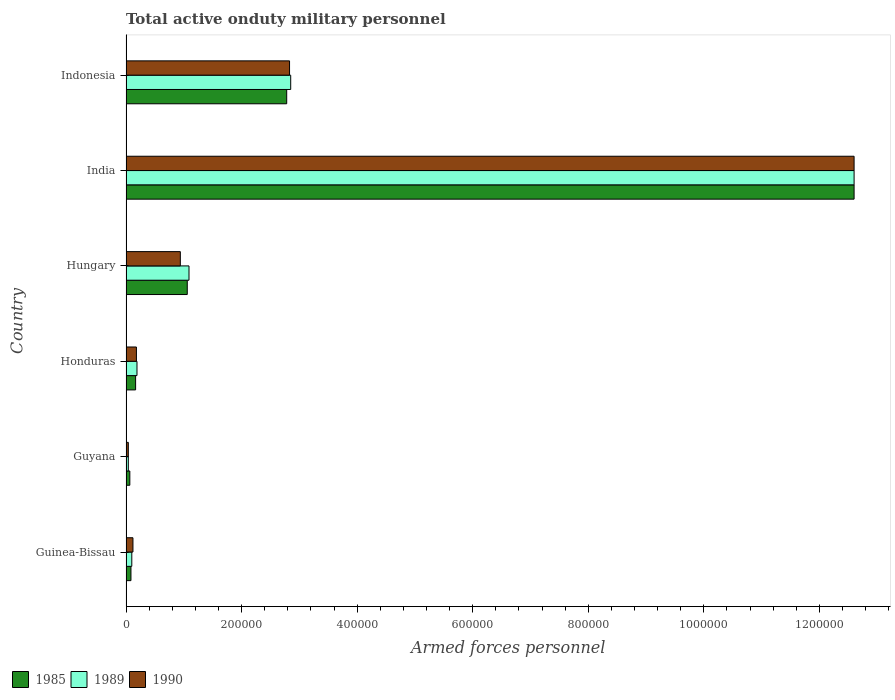Are the number of bars per tick equal to the number of legend labels?
Your answer should be very brief. Yes. How many bars are there on the 3rd tick from the top?
Ensure brevity in your answer.  3. What is the number of armed forces personnel in 1985 in Guyana?
Your response must be concise. 6600. Across all countries, what is the maximum number of armed forces personnel in 1989?
Your answer should be compact. 1.26e+06. Across all countries, what is the minimum number of armed forces personnel in 1989?
Keep it short and to the point. 4000. In which country was the number of armed forces personnel in 1985 minimum?
Give a very brief answer. Guyana. What is the total number of armed forces personnel in 1990 in the graph?
Offer a terse response. 1.67e+06. What is the difference between the number of armed forces personnel in 1985 in Hungary and that in India?
Give a very brief answer. -1.15e+06. What is the difference between the number of armed forces personnel in 1989 in Honduras and the number of armed forces personnel in 1985 in Hungary?
Offer a terse response. -8.70e+04. What is the average number of armed forces personnel in 1990 per country?
Make the answer very short. 2.78e+05. In how many countries, is the number of armed forces personnel in 1989 greater than 440000 ?
Keep it short and to the point. 1. What is the ratio of the number of armed forces personnel in 1990 in Hungary to that in Indonesia?
Your answer should be compact. 0.33. Is the difference between the number of armed forces personnel in 1989 in Honduras and India greater than the difference between the number of armed forces personnel in 1990 in Honduras and India?
Ensure brevity in your answer.  Yes. What is the difference between the highest and the second highest number of armed forces personnel in 1985?
Your answer should be compact. 9.82e+05. What is the difference between the highest and the lowest number of armed forces personnel in 1989?
Offer a very short reply. 1.26e+06. What does the 1st bar from the top in Indonesia represents?
Ensure brevity in your answer.  1990. What does the 3rd bar from the bottom in Guinea-Bissau represents?
Your response must be concise. 1990. Is it the case that in every country, the sum of the number of armed forces personnel in 1990 and number of armed forces personnel in 1989 is greater than the number of armed forces personnel in 1985?
Give a very brief answer. Yes. How many bars are there?
Offer a very short reply. 18. How many countries are there in the graph?
Offer a terse response. 6. What is the difference between two consecutive major ticks on the X-axis?
Ensure brevity in your answer.  2.00e+05. What is the title of the graph?
Keep it short and to the point. Total active onduty military personnel. What is the label or title of the X-axis?
Ensure brevity in your answer.  Armed forces personnel. What is the label or title of the Y-axis?
Keep it short and to the point. Country. What is the Armed forces personnel of 1985 in Guinea-Bissau?
Give a very brief answer. 8550. What is the Armed forces personnel in 1989 in Guinea-Bissau?
Offer a terse response. 10000. What is the Armed forces personnel of 1990 in Guinea-Bissau?
Ensure brevity in your answer.  1.20e+04. What is the Armed forces personnel of 1985 in Guyana?
Provide a short and direct response. 6600. What is the Armed forces personnel in 1989 in Guyana?
Provide a succinct answer. 4000. What is the Armed forces personnel in 1990 in Guyana?
Provide a short and direct response. 4000. What is the Armed forces personnel in 1985 in Honduras?
Give a very brief answer. 1.66e+04. What is the Armed forces personnel in 1989 in Honduras?
Make the answer very short. 1.90e+04. What is the Armed forces personnel in 1990 in Honduras?
Offer a very short reply. 1.80e+04. What is the Armed forces personnel of 1985 in Hungary?
Your answer should be compact. 1.06e+05. What is the Armed forces personnel in 1989 in Hungary?
Offer a very short reply. 1.09e+05. What is the Armed forces personnel in 1990 in Hungary?
Make the answer very short. 9.40e+04. What is the Armed forces personnel in 1985 in India?
Provide a short and direct response. 1.26e+06. What is the Armed forces personnel in 1989 in India?
Your response must be concise. 1.26e+06. What is the Armed forces personnel in 1990 in India?
Offer a terse response. 1.26e+06. What is the Armed forces personnel of 1985 in Indonesia?
Your answer should be compact. 2.78e+05. What is the Armed forces personnel of 1989 in Indonesia?
Ensure brevity in your answer.  2.85e+05. What is the Armed forces personnel of 1990 in Indonesia?
Make the answer very short. 2.83e+05. Across all countries, what is the maximum Armed forces personnel in 1985?
Give a very brief answer. 1.26e+06. Across all countries, what is the maximum Armed forces personnel in 1989?
Your response must be concise. 1.26e+06. Across all countries, what is the maximum Armed forces personnel of 1990?
Provide a short and direct response. 1.26e+06. Across all countries, what is the minimum Armed forces personnel in 1985?
Ensure brevity in your answer.  6600. Across all countries, what is the minimum Armed forces personnel of 1989?
Ensure brevity in your answer.  4000. Across all countries, what is the minimum Armed forces personnel of 1990?
Keep it short and to the point. 4000. What is the total Armed forces personnel of 1985 in the graph?
Your answer should be very brief. 1.68e+06. What is the total Armed forces personnel of 1989 in the graph?
Provide a succinct answer. 1.69e+06. What is the total Armed forces personnel in 1990 in the graph?
Make the answer very short. 1.67e+06. What is the difference between the Armed forces personnel in 1985 in Guinea-Bissau and that in Guyana?
Your answer should be compact. 1950. What is the difference between the Armed forces personnel in 1989 in Guinea-Bissau and that in Guyana?
Provide a short and direct response. 6000. What is the difference between the Armed forces personnel of 1990 in Guinea-Bissau and that in Guyana?
Provide a short and direct response. 8000. What is the difference between the Armed forces personnel in 1985 in Guinea-Bissau and that in Honduras?
Give a very brief answer. -8050. What is the difference between the Armed forces personnel in 1989 in Guinea-Bissau and that in Honduras?
Ensure brevity in your answer.  -9000. What is the difference between the Armed forces personnel in 1990 in Guinea-Bissau and that in Honduras?
Offer a terse response. -6000. What is the difference between the Armed forces personnel in 1985 in Guinea-Bissau and that in Hungary?
Your response must be concise. -9.74e+04. What is the difference between the Armed forces personnel in 1989 in Guinea-Bissau and that in Hungary?
Your answer should be compact. -9.90e+04. What is the difference between the Armed forces personnel of 1990 in Guinea-Bissau and that in Hungary?
Your response must be concise. -8.20e+04. What is the difference between the Armed forces personnel of 1985 in Guinea-Bissau and that in India?
Make the answer very short. -1.25e+06. What is the difference between the Armed forces personnel in 1989 in Guinea-Bissau and that in India?
Give a very brief answer. -1.25e+06. What is the difference between the Armed forces personnel in 1990 in Guinea-Bissau and that in India?
Give a very brief answer. -1.25e+06. What is the difference between the Armed forces personnel in 1985 in Guinea-Bissau and that in Indonesia?
Your response must be concise. -2.70e+05. What is the difference between the Armed forces personnel of 1989 in Guinea-Bissau and that in Indonesia?
Provide a succinct answer. -2.75e+05. What is the difference between the Armed forces personnel in 1990 in Guinea-Bissau and that in Indonesia?
Offer a very short reply. -2.71e+05. What is the difference between the Armed forces personnel in 1985 in Guyana and that in Honduras?
Offer a very short reply. -10000. What is the difference between the Armed forces personnel in 1989 in Guyana and that in Honduras?
Your answer should be very brief. -1.50e+04. What is the difference between the Armed forces personnel of 1990 in Guyana and that in Honduras?
Provide a short and direct response. -1.40e+04. What is the difference between the Armed forces personnel of 1985 in Guyana and that in Hungary?
Provide a short and direct response. -9.94e+04. What is the difference between the Armed forces personnel in 1989 in Guyana and that in Hungary?
Ensure brevity in your answer.  -1.05e+05. What is the difference between the Armed forces personnel of 1990 in Guyana and that in Hungary?
Provide a short and direct response. -9.00e+04. What is the difference between the Armed forces personnel in 1985 in Guyana and that in India?
Your answer should be compact. -1.25e+06. What is the difference between the Armed forces personnel in 1989 in Guyana and that in India?
Provide a succinct answer. -1.26e+06. What is the difference between the Armed forces personnel in 1990 in Guyana and that in India?
Make the answer very short. -1.26e+06. What is the difference between the Armed forces personnel in 1985 in Guyana and that in Indonesia?
Keep it short and to the point. -2.72e+05. What is the difference between the Armed forces personnel in 1989 in Guyana and that in Indonesia?
Keep it short and to the point. -2.81e+05. What is the difference between the Armed forces personnel in 1990 in Guyana and that in Indonesia?
Your answer should be very brief. -2.79e+05. What is the difference between the Armed forces personnel in 1985 in Honduras and that in Hungary?
Your answer should be compact. -8.94e+04. What is the difference between the Armed forces personnel in 1989 in Honduras and that in Hungary?
Your answer should be compact. -9.00e+04. What is the difference between the Armed forces personnel in 1990 in Honduras and that in Hungary?
Make the answer very short. -7.60e+04. What is the difference between the Armed forces personnel of 1985 in Honduras and that in India?
Make the answer very short. -1.24e+06. What is the difference between the Armed forces personnel in 1989 in Honduras and that in India?
Offer a very short reply. -1.24e+06. What is the difference between the Armed forces personnel of 1990 in Honduras and that in India?
Make the answer very short. -1.24e+06. What is the difference between the Armed forces personnel in 1985 in Honduras and that in Indonesia?
Your answer should be very brief. -2.62e+05. What is the difference between the Armed forces personnel in 1989 in Honduras and that in Indonesia?
Make the answer very short. -2.66e+05. What is the difference between the Armed forces personnel in 1990 in Honduras and that in Indonesia?
Ensure brevity in your answer.  -2.65e+05. What is the difference between the Armed forces personnel of 1985 in Hungary and that in India?
Ensure brevity in your answer.  -1.15e+06. What is the difference between the Armed forces personnel in 1989 in Hungary and that in India?
Ensure brevity in your answer.  -1.15e+06. What is the difference between the Armed forces personnel of 1990 in Hungary and that in India?
Provide a short and direct response. -1.17e+06. What is the difference between the Armed forces personnel in 1985 in Hungary and that in Indonesia?
Provide a short and direct response. -1.72e+05. What is the difference between the Armed forces personnel of 1989 in Hungary and that in Indonesia?
Give a very brief answer. -1.76e+05. What is the difference between the Armed forces personnel in 1990 in Hungary and that in Indonesia?
Give a very brief answer. -1.89e+05. What is the difference between the Armed forces personnel in 1985 in India and that in Indonesia?
Offer a very short reply. 9.82e+05. What is the difference between the Armed forces personnel of 1989 in India and that in Indonesia?
Your response must be concise. 9.75e+05. What is the difference between the Armed forces personnel of 1990 in India and that in Indonesia?
Ensure brevity in your answer.  9.77e+05. What is the difference between the Armed forces personnel of 1985 in Guinea-Bissau and the Armed forces personnel of 1989 in Guyana?
Offer a very short reply. 4550. What is the difference between the Armed forces personnel of 1985 in Guinea-Bissau and the Armed forces personnel of 1990 in Guyana?
Ensure brevity in your answer.  4550. What is the difference between the Armed forces personnel of 1989 in Guinea-Bissau and the Armed forces personnel of 1990 in Guyana?
Your response must be concise. 6000. What is the difference between the Armed forces personnel of 1985 in Guinea-Bissau and the Armed forces personnel of 1989 in Honduras?
Provide a succinct answer. -1.04e+04. What is the difference between the Armed forces personnel of 1985 in Guinea-Bissau and the Armed forces personnel of 1990 in Honduras?
Provide a succinct answer. -9450. What is the difference between the Armed forces personnel of 1989 in Guinea-Bissau and the Armed forces personnel of 1990 in Honduras?
Provide a succinct answer. -8000. What is the difference between the Armed forces personnel in 1985 in Guinea-Bissau and the Armed forces personnel in 1989 in Hungary?
Your answer should be compact. -1.00e+05. What is the difference between the Armed forces personnel in 1985 in Guinea-Bissau and the Armed forces personnel in 1990 in Hungary?
Provide a short and direct response. -8.54e+04. What is the difference between the Armed forces personnel of 1989 in Guinea-Bissau and the Armed forces personnel of 1990 in Hungary?
Keep it short and to the point. -8.40e+04. What is the difference between the Armed forces personnel in 1985 in Guinea-Bissau and the Armed forces personnel in 1989 in India?
Provide a succinct answer. -1.25e+06. What is the difference between the Armed forces personnel of 1985 in Guinea-Bissau and the Armed forces personnel of 1990 in India?
Your answer should be very brief. -1.25e+06. What is the difference between the Armed forces personnel of 1989 in Guinea-Bissau and the Armed forces personnel of 1990 in India?
Ensure brevity in your answer.  -1.25e+06. What is the difference between the Armed forces personnel of 1985 in Guinea-Bissau and the Armed forces personnel of 1989 in Indonesia?
Make the answer very short. -2.76e+05. What is the difference between the Armed forces personnel in 1985 in Guinea-Bissau and the Armed forces personnel in 1990 in Indonesia?
Make the answer very short. -2.74e+05. What is the difference between the Armed forces personnel of 1989 in Guinea-Bissau and the Armed forces personnel of 1990 in Indonesia?
Offer a terse response. -2.73e+05. What is the difference between the Armed forces personnel in 1985 in Guyana and the Armed forces personnel in 1989 in Honduras?
Provide a short and direct response. -1.24e+04. What is the difference between the Armed forces personnel of 1985 in Guyana and the Armed forces personnel of 1990 in Honduras?
Make the answer very short. -1.14e+04. What is the difference between the Armed forces personnel of 1989 in Guyana and the Armed forces personnel of 1990 in Honduras?
Make the answer very short. -1.40e+04. What is the difference between the Armed forces personnel of 1985 in Guyana and the Armed forces personnel of 1989 in Hungary?
Your answer should be very brief. -1.02e+05. What is the difference between the Armed forces personnel in 1985 in Guyana and the Armed forces personnel in 1990 in Hungary?
Give a very brief answer. -8.74e+04. What is the difference between the Armed forces personnel in 1985 in Guyana and the Armed forces personnel in 1989 in India?
Offer a very short reply. -1.25e+06. What is the difference between the Armed forces personnel in 1985 in Guyana and the Armed forces personnel in 1990 in India?
Provide a succinct answer. -1.25e+06. What is the difference between the Armed forces personnel in 1989 in Guyana and the Armed forces personnel in 1990 in India?
Your answer should be compact. -1.26e+06. What is the difference between the Armed forces personnel in 1985 in Guyana and the Armed forces personnel in 1989 in Indonesia?
Provide a short and direct response. -2.78e+05. What is the difference between the Armed forces personnel in 1985 in Guyana and the Armed forces personnel in 1990 in Indonesia?
Ensure brevity in your answer.  -2.76e+05. What is the difference between the Armed forces personnel in 1989 in Guyana and the Armed forces personnel in 1990 in Indonesia?
Your response must be concise. -2.79e+05. What is the difference between the Armed forces personnel in 1985 in Honduras and the Armed forces personnel in 1989 in Hungary?
Keep it short and to the point. -9.24e+04. What is the difference between the Armed forces personnel in 1985 in Honduras and the Armed forces personnel in 1990 in Hungary?
Keep it short and to the point. -7.74e+04. What is the difference between the Armed forces personnel of 1989 in Honduras and the Armed forces personnel of 1990 in Hungary?
Offer a very short reply. -7.50e+04. What is the difference between the Armed forces personnel of 1985 in Honduras and the Armed forces personnel of 1989 in India?
Your answer should be compact. -1.24e+06. What is the difference between the Armed forces personnel of 1985 in Honduras and the Armed forces personnel of 1990 in India?
Ensure brevity in your answer.  -1.24e+06. What is the difference between the Armed forces personnel of 1989 in Honduras and the Armed forces personnel of 1990 in India?
Provide a short and direct response. -1.24e+06. What is the difference between the Armed forces personnel in 1985 in Honduras and the Armed forces personnel in 1989 in Indonesia?
Your response must be concise. -2.68e+05. What is the difference between the Armed forces personnel in 1985 in Honduras and the Armed forces personnel in 1990 in Indonesia?
Provide a short and direct response. -2.66e+05. What is the difference between the Armed forces personnel in 1989 in Honduras and the Armed forces personnel in 1990 in Indonesia?
Make the answer very short. -2.64e+05. What is the difference between the Armed forces personnel in 1985 in Hungary and the Armed forces personnel in 1989 in India?
Give a very brief answer. -1.15e+06. What is the difference between the Armed forces personnel of 1985 in Hungary and the Armed forces personnel of 1990 in India?
Your response must be concise. -1.15e+06. What is the difference between the Armed forces personnel in 1989 in Hungary and the Armed forces personnel in 1990 in India?
Provide a succinct answer. -1.15e+06. What is the difference between the Armed forces personnel of 1985 in Hungary and the Armed forces personnel of 1989 in Indonesia?
Make the answer very short. -1.79e+05. What is the difference between the Armed forces personnel in 1985 in Hungary and the Armed forces personnel in 1990 in Indonesia?
Make the answer very short. -1.77e+05. What is the difference between the Armed forces personnel of 1989 in Hungary and the Armed forces personnel of 1990 in Indonesia?
Offer a terse response. -1.74e+05. What is the difference between the Armed forces personnel of 1985 in India and the Armed forces personnel of 1989 in Indonesia?
Make the answer very short. 9.75e+05. What is the difference between the Armed forces personnel of 1985 in India and the Armed forces personnel of 1990 in Indonesia?
Keep it short and to the point. 9.77e+05. What is the difference between the Armed forces personnel in 1989 in India and the Armed forces personnel in 1990 in Indonesia?
Make the answer very short. 9.77e+05. What is the average Armed forces personnel of 1985 per country?
Offer a very short reply. 2.79e+05. What is the average Armed forces personnel of 1989 per country?
Your answer should be compact. 2.81e+05. What is the average Armed forces personnel of 1990 per country?
Your answer should be compact. 2.78e+05. What is the difference between the Armed forces personnel in 1985 and Armed forces personnel in 1989 in Guinea-Bissau?
Make the answer very short. -1450. What is the difference between the Armed forces personnel in 1985 and Armed forces personnel in 1990 in Guinea-Bissau?
Provide a short and direct response. -3450. What is the difference between the Armed forces personnel of 1989 and Armed forces personnel of 1990 in Guinea-Bissau?
Your response must be concise. -2000. What is the difference between the Armed forces personnel of 1985 and Armed forces personnel of 1989 in Guyana?
Keep it short and to the point. 2600. What is the difference between the Armed forces personnel in 1985 and Armed forces personnel in 1990 in Guyana?
Keep it short and to the point. 2600. What is the difference between the Armed forces personnel in 1985 and Armed forces personnel in 1989 in Honduras?
Offer a very short reply. -2400. What is the difference between the Armed forces personnel of 1985 and Armed forces personnel of 1990 in Honduras?
Make the answer very short. -1400. What is the difference between the Armed forces personnel in 1985 and Armed forces personnel in 1989 in Hungary?
Ensure brevity in your answer.  -3000. What is the difference between the Armed forces personnel of 1985 and Armed forces personnel of 1990 in Hungary?
Offer a very short reply. 1.20e+04. What is the difference between the Armed forces personnel in 1989 and Armed forces personnel in 1990 in Hungary?
Ensure brevity in your answer.  1.50e+04. What is the difference between the Armed forces personnel of 1985 and Armed forces personnel of 1990 in India?
Keep it short and to the point. 0. What is the difference between the Armed forces personnel in 1989 and Armed forces personnel in 1990 in India?
Your answer should be very brief. 0. What is the difference between the Armed forces personnel of 1985 and Armed forces personnel of 1989 in Indonesia?
Make the answer very short. -6900. What is the difference between the Armed forces personnel in 1985 and Armed forces personnel in 1990 in Indonesia?
Your answer should be compact. -4900. What is the difference between the Armed forces personnel of 1989 and Armed forces personnel of 1990 in Indonesia?
Your answer should be very brief. 2000. What is the ratio of the Armed forces personnel in 1985 in Guinea-Bissau to that in Guyana?
Keep it short and to the point. 1.3. What is the ratio of the Armed forces personnel of 1989 in Guinea-Bissau to that in Guyana?
Give a very brief answer. 2.5. What is the ratio of the Armed forces personnel of 1990 in Guinea-Bissau to that in Guyana?
Make the answer very short. 3. What is the ratio of the Armed forces personnel in 1985 in Guinea-Bissau to that in Honduras?
Offer a terse response. 0.52. What is the ratio of the Armed forces personnel in 1989 in Guinea-Bissau to that in Honduras?
Keep it short and to the point. 0.53. What is the ratio of the Armed forces personnel in 1985 in Guinea-Bissau to that in Hungary?
Your response must be concise. 0.08. What is the ratio of the Armed forces personnel of 1989 in Guinea-Bissau to that in Hungary?
Your response must be concise. 0.09. What is the ratio of the Armed forces personnel of 1990 in Guinea-Bissau to that in Hungary?
Ensure brevity in your answer.  0.13. What is the ratio of the Armed forces personnel of 1985 in Guinea-Bissau to that in India?
Your response must be concise. 0.01. What is the ratio of the Armed forces personnel of 1989 in Guinea-Bissau to that in India?
Your answer should be very brief. 0.01. What is the ratio of the Armed forces personnel in 1990 in Guinea-Bissau to that in India?
Offer a very short reply. 0.01. What is the ratio of the Armed forces personnel of 1985 in Guinea-Bissau to that in Indonesia?
Your answer should be compact. 0.03. What is the ratio of the Armed forces personnel of 1989 in Guinea-Bissau to that in Indonesia?
Your answer should be very brief. 0.04. What is the ratio of the Armed forces personnel in 1990 in Guinea-Bissau to that in Indonesia?
Provide a short and direct response. 0.04. What is the ratio of the Armed forces personnel of 1985 in Guyana to that in Honduras?
Ensure brevity in your answer.  0.4. What is the ratio of the Armed forces personnel of 1989 in Guyana to that in Honduras?
Provide a short and direct response. 0.21. What is the ratio of the Armed forces personnel of 1990 in Guyana to that in Honduras?
Your response must be concise. 0.22. What is the ratio of the Armed forces personnel of 1985 in Guyana to that in Hungary?
Give a very brief answer. 0.06. What is the ratio of the Armed forces personnel in 1989 in Guyana to that in Hungary?
Offer a very short reply. 0.04. What is the ratio of the Armed forces personnel of 1990 in Guyana to that in Hungary?
Ensure brevity in your answer.  0.04. What is the ratio of the Armed forces personnel of 1985 in Guyana to that in India?
Give a very brief answer. 0.01. What is the ratio of the Armed forces personnel of 1989 in Guyana to that in India?
Give a very brief answer. 0. What is the ratio of the Armed forces personnel in 1990 in Guyana to that in India?
Your answer should be very brief. 0. What is the ratio of the Armed forces personnel of 1985 in Guyana to that in Indonesia?
Provide a short and direct response. 0.02. What is the ratio of the Armed forces personnel of 1989 in Guyana to that in Indonesia?
Give a very brief answer. 0.01. What is the ratio of the Armed forces personnel of 1990 in Guyana to that in Indonesia?
Provide a short and direct response. 0.01. What is the ratio of the Armed forces personnel of 1985 in Honduras to that in Hungary?
Make the answer very short. 0.16. What is the ratio of the Armed forces personnel in 1989 in Honduras to that in Hungary?
Offer a terse response. 0.17. What is the ratio of the Armed forces personnel in 1990 in Honduras to that in Hungary?
Your answer should be very brief. 0.19. What is the ratio of the Armed forces personnel of 1985 in Honduras to that in India?
Your response must be concise. 0.01. What is the ratio of the Armed forces personnel in 1989 in Honduras to that in India?
Provide a short and direct response. 0.02. What is the ratio of the Armed forces personnel in 1990 in Honduras to that in India?
Make the answer very short. 0.01. What is the ratio of the Armed forces personnel of 1985 in Honduras to that in Indonesia?
Provide a short and direct response. 0.06. What is the ratio of the Armed forces personnel of 1989 in Honduras to that in Indonesia?
Your response must be concise. 0.07. What is the ratio of the Armed forces personnel in 1990 in Honduras to that in Indonesia?
Your response must be concise. 0.06. What is the ratio of the Armed forces personnel of 1985 in Hungary to that in India?
Keep it short and to the point. 0.08. What is the ratio of the Armed forces personnel in 1989 in Hungary to that in India?
Offer a very short reply. 0.09. What is the ratio of the Armed forces personnel of 1990 in Hungary to that in India?
Offer a very short reply. 0.07. What is the ratio of the Armed forces personnel in 1985 in Hungary to that in Indonesia?
Provide a succinct answer. 0.38. What is the ratio of the Armed forces personnel of 1989 in Hungary to that in Indonesia?
Your answer should be compact. 0.38. What is the ratio of the Armed forces personnel in 1990 in Hungary to that in Indonesia?
Offer a very short reply. 0.33. What is the ratio of the Armed forces personnel in 1985 in India to that in Indonesia?
Give a very brief answer. 4.53. What is the ratio of the Armed forces personnel in 1989 in India to that in Indonesia?
Your response must be concise. 4.42. What is the ratio of the Armed forces personnel of 1990 in India to that in Indonesia?
Provide a short and direct response. 4.45. What is the difference between the highest and the second highest Armed forces personnel in 1985?
Keep it short and to the point. 9.82e+05. What is the difference between the highest and the second highest Armed forces personnel in 1989?
Your answer should be compact. 9.75e+05. What is the difference between the highest and the second highest Armed forces personnel in 1990?
Make the answer very short. 9.77e+05. What is the difference between the highest and the lowest Armed forces personnel in 1985?
Keep it short and to the point. 1.25e+06. What is the difference between the highest and the lowest Armed forces personnel in 1989?
Offer a terse response. 1.26e+06. What is the difference between the highest and the lowest Armed forces personnel in 1990?
Offer a terse response. 1.26e+06. 